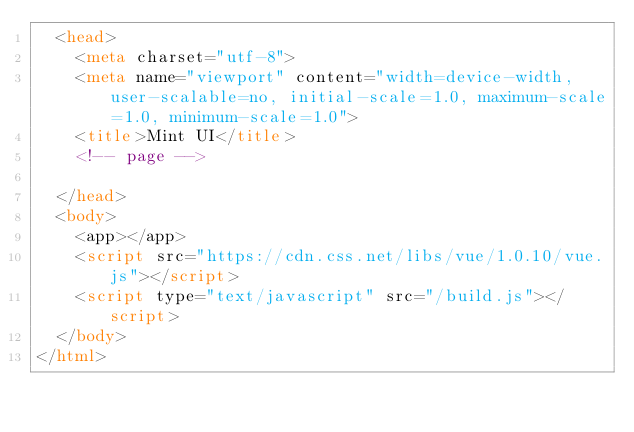<code> <loc_0><loc_0><loc_500><loc_500><_HTML_>  <head>
    <meta charset="utf-8">
    <meta name="viewport" content="width=device-width, user-scalable=no, initial-scale=1.0, maximum-scale=1.0, minimum-scale=1.0">
    <title>Mint UI</title>
    <!-- page -->

  </head>
  <body>
    <app></app>
    <script src="https://cdn.css.net/libs/vue/1.0.10/vue.js"></script>
    <script type="text/javascript" src="/build.js"></script>
  </body>
</html>
</code> 